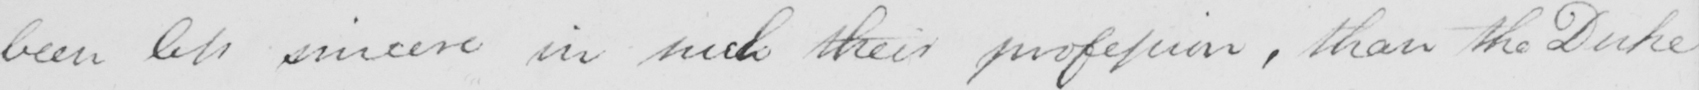Transcribe the text shown in this historical manuscript line. been less sincere in such their profession , than the Duke 